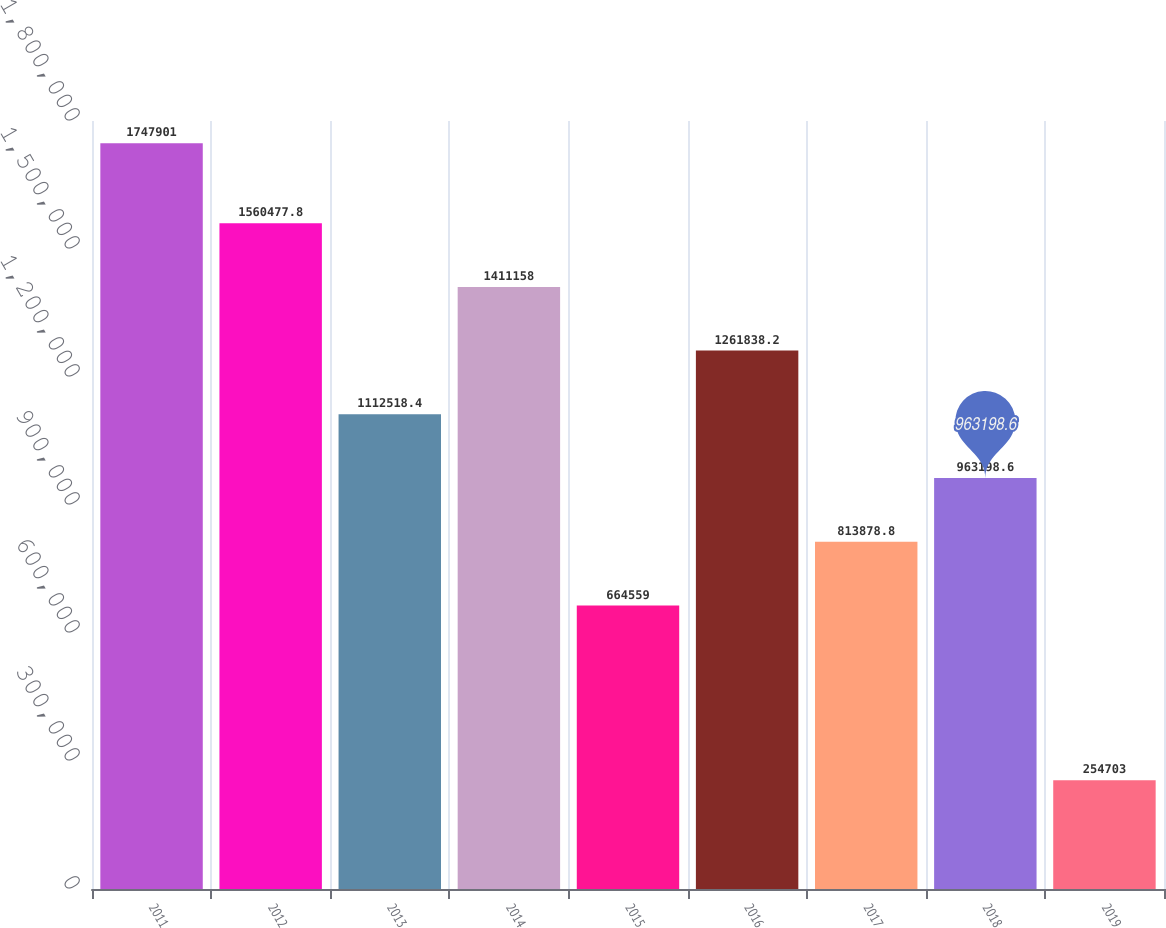Convert chart. <chart><loc_0><loc_0><loc_500><loc_500><bar_chart><fcel>2011<fcel>2012<fcel>2013<fcel>2014<fcel>2015<fcel>2016<fcel>2017<fcel>2018<fcel>2019<nl><fcel>1.7479e+06<fcel>1.56048e+06<fcel>1.11252e+06<fcel>1.41116e+06<fcel>664559<fcel>1.26184e+06<fcel>813879<fcel>963199<fcel>254703<nl></chart> 